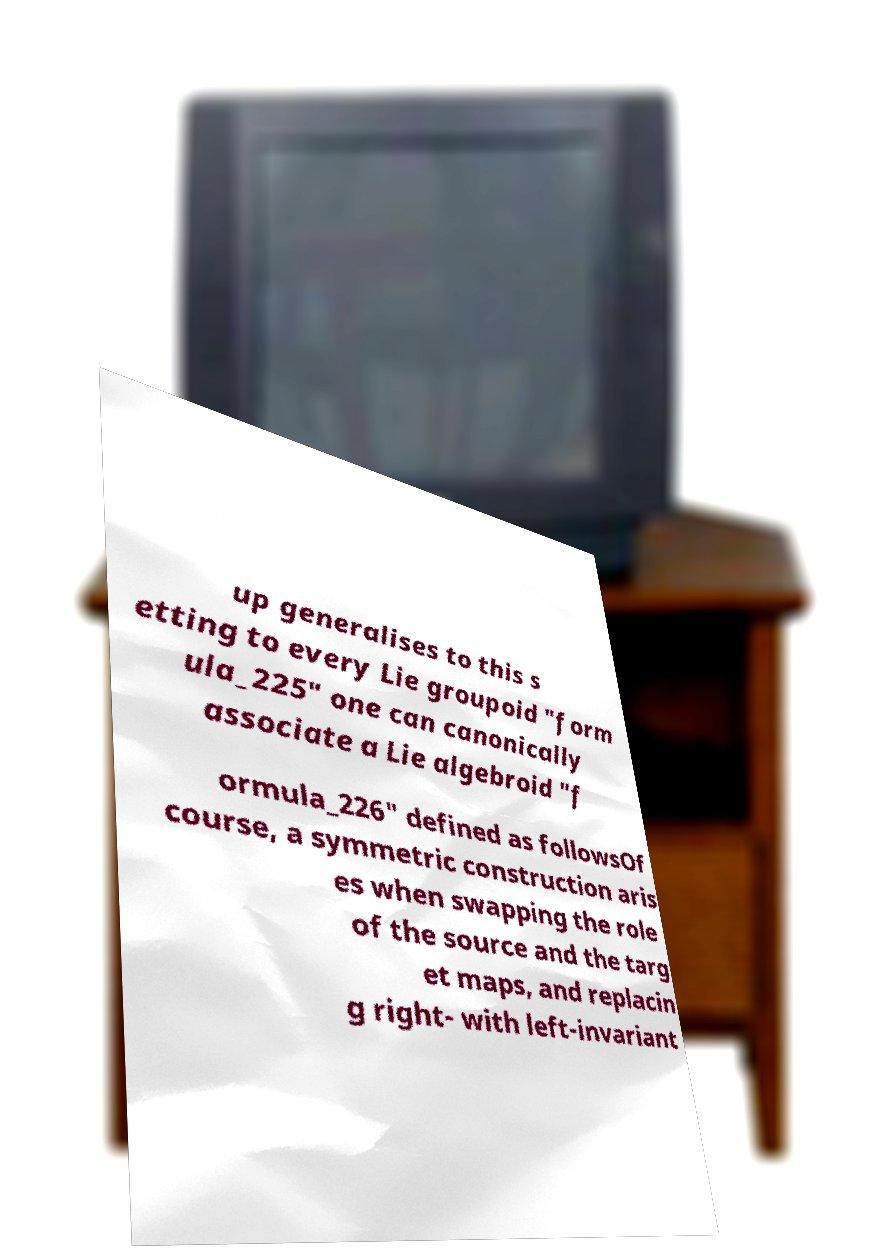For documentation purposes, I need the text within this image transcribed. Could you provide that? up generalises to this s etting to every Lie groupoid "form ula_225" one can canonically associate a Lie algebroid "f ormula_226" defined as followsOf course, a symmetric construction aris es when swapping the role of the source and the targ et maps, and replacin g right- with left-invariant 